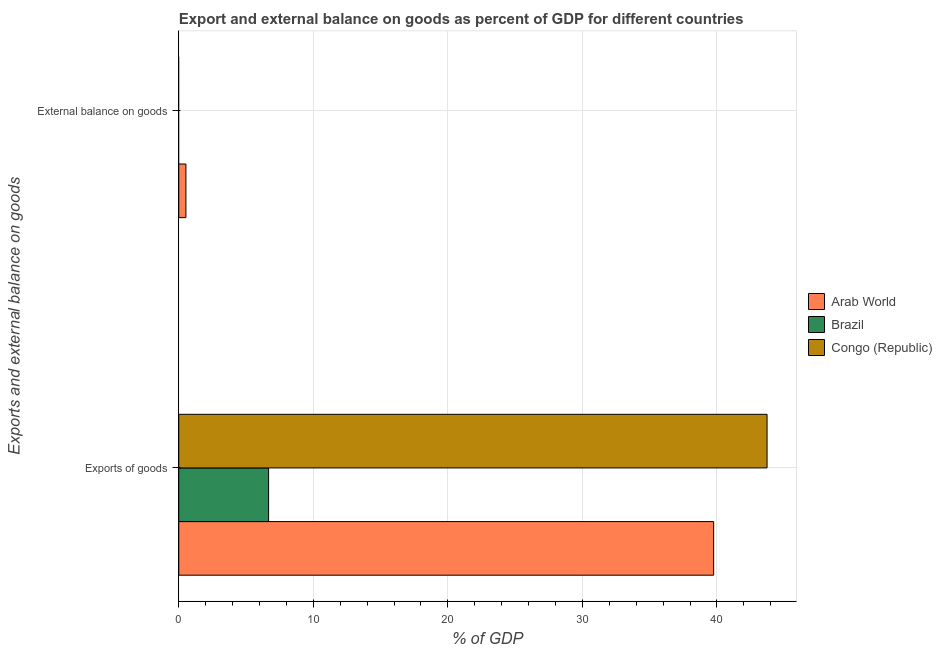Are the number of bars per tick equal to the number of legend labels?
Your answer should be very brief. No. Are the number of bars on each tick of the Y-axis equal?
Your answer should be very brief. No. How many bars are there on the 1st tick from the top?
Provide a short and direct response. 1. How many bars are there on the 1st tick from the bottom?
Your response must be concise. 3. What is the label of the 2nd group of bars from the top?
Offer a very short reply. Exports of goods. What is the external balance on goods as percentage of gdp in Arab World?
Offer a terse response. 0.53. Across all countries, what is the maximum external balance on goods as percentage of gdp?
Provide a succinct answer. 0.53. Across all countries, what is the minimum export of goods as percentage of gdp?
Offer a very short reply. 6.68. In which country was the external balance on goods as percentage of gdp maximum?
Give a very brief answer. Arab World. What is the total external balance on goods as percentage of gdp in the graph?
Give a very brief answer. 0.53. What is the difference between the export of goods as percentage of gdp in Arab World and that in Congo (Republic)?
Your answer should be very brief. -3.97. What is the difference between the export of goods as percentage of gdp in Brazil and the external balance on goods as percentage of gdp in Arab World?
Give a very brief answer. 6.14. What is the average external balance on goods as percentage of gdp per country?
Give a very brief answer. 0.18. What is the difference between the external balance on goods as percentage of gdp and export of goods as percentage of gdp in Arab World?
Keep it short and to the point. -39.22. What is the ratio of the export of goods as percentage of gdp in Brazil to that in Arab World?
Keep it short and to the point. 0.17. What is the difference between two consecutive major ticks on the X-axis?
Provide a short and direct response. 10. Are the values on the major ticks of X-axis written in scientific E-notation?
Your answer should be compact. No. Does the graph contain any zero values?
Provide a short and direct response. Yes. Does the graph contain grids?
Ensure brevity in your answer.  Yes. How many legend labels are there?
Make the answer very short. 3. How are the legend labels stacked?
Offer a terse response. Vertical. What is the title of the graph?
Offer a very short reply. Export and external balance on goods as percent of GDP for different countries. What is the label or title of the X-axis?
Provide a succinct answer. % of GDP. What is the label or title of the Y-axis?
Keep it short and to the point. Exports and external balance on goods. What is the % of GDP in Arab World in Exports of goods?
Provide a short and direct response. 39.75. What is the % of GDP in Brazil in Exports of goods?
Your response must be concise. 6.68. What is the % of GDP in Congo (Republic) in Exports of goods?
Make the answer very short. 43.72. What is the % of GDP of Arab World in External balance on goods?
Your response must be concise. 0.53. What is the % of GDP of Brazil in External balance on goods?
Provide a succinct answer. 0. What is the % of GDP in Congo (Republic) in External balance on goods?
Make the answer very short. 0. Across all Exports and external balance on goods, what is the maximum % of GDP in Arab World?
Ensure brevity in your answer.  39.75. Across all Exports and external balance on goods, what is the maximum % of GDP in Brazil?
Offer a terse response. 6.68. Across all Exports and external balance on goods, what is the maximum % of GDP of Congo (Republic)?
Make the answer very short. 43.72. Across all Exports and external balance on goods, what is the minimum % of GDP in Arab World?
Provide a short and direct response. 0.53. Across all Exports and external balance on goods, what is the minimum % of GDP of Brazil?
Provide a succinct answer. 0. What is the total % of GDP in Arab World in the graph?
Your answer should be compact. 40.28. What is the total % of GDP in Brazil in the graph?
Keep it short and to the point. 6.68. What is the total % of GDP of Congo (Republic) in the graph?
Your response must be concise. 43.72. What is the difference between the % of GDP of Arab World in Exports of goods and that in External balance on goods?
Your answer should be very brief. 39.22. What is the average % of GDP of Arab World per Exports and external balance on goods?
Provide a succinct answer. 20.14. What is the average % of GDP of Brazil per Exports and external balance on goods?
Provide a short and direct response. 3.34. What is the average % of GDP in Congo (Republic) per Exports and external balance on goods?
Offer a very short reply. 21.86. What is the difference between the % of GDP of Arab World and % of GDP of Brazil in Exports of goods?
Make the answer very short. 33.08. What is the difference between the % of GDP of Arab World and % of GDP of Congo (Republic) in Exports of goods?
Make the answer very short. -3.97. What is the difference between the % of GDP of Brazil and % of GDP of Congo (Republic) in Exports of goods?
Provide a succinct answer. -37.05. What is the ratio of the % of GDP in Arab World in Exports of goods to that in External balance on goods?
Provide a short and direct response. 74.76. What is the difference between the highest and the second highest % of GDP in Arab World?
Your answer should be very brief. 39.22. What is the difference between the highest and the lowest % of GDP of Arab World?
Make the answer very short. 39.22. What is the difference between the highest and the lowest % of GDP in Brazil?
Your response must be concise. 6.68. What is the difference between the highest and the lowest % of GDP of Congo (Republic)?
Your answer should be compact. 43.72. 